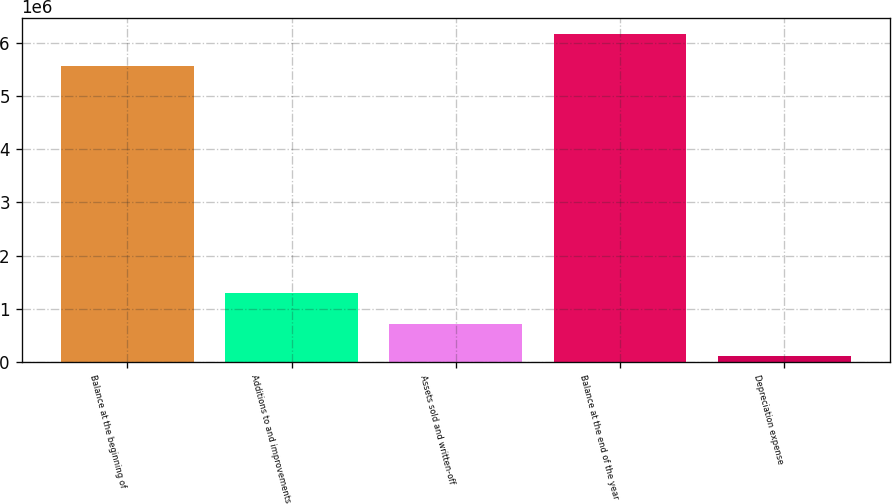Convert chart. <chart><loc_0><loc_0><loc_500><loc_500><bar_chart><fcel>Balance at the beginning of<fcel>Additions to and improvements<fcel>Assets sold and written-off<fcel>Balance at the end of the year<fcel>Depreciation expense<nl><fcel>5.57089e+06<fcel>1.30596e+06<fcel>712352<fcel>6.16449e+06<fcel>118748<nl></chart> 